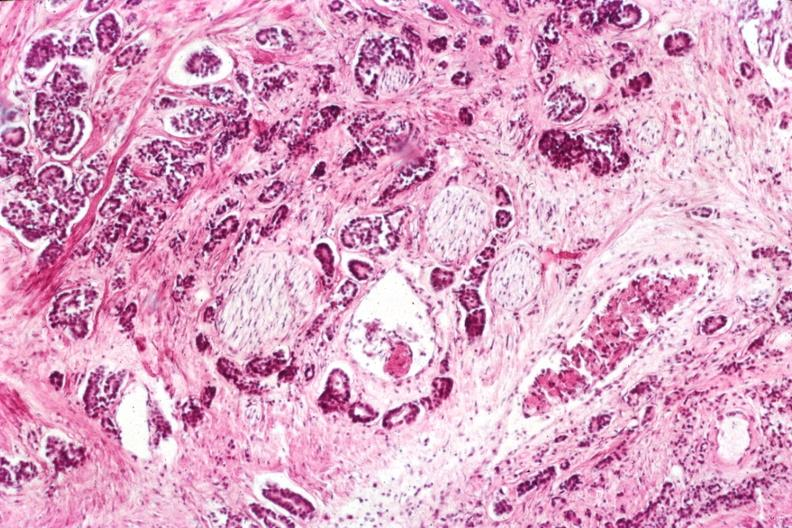what does this image show?
Answer the question using a single word or phrase. Very nice view of infiltrating neoplasm with perineural invasion typical prostate lesion 